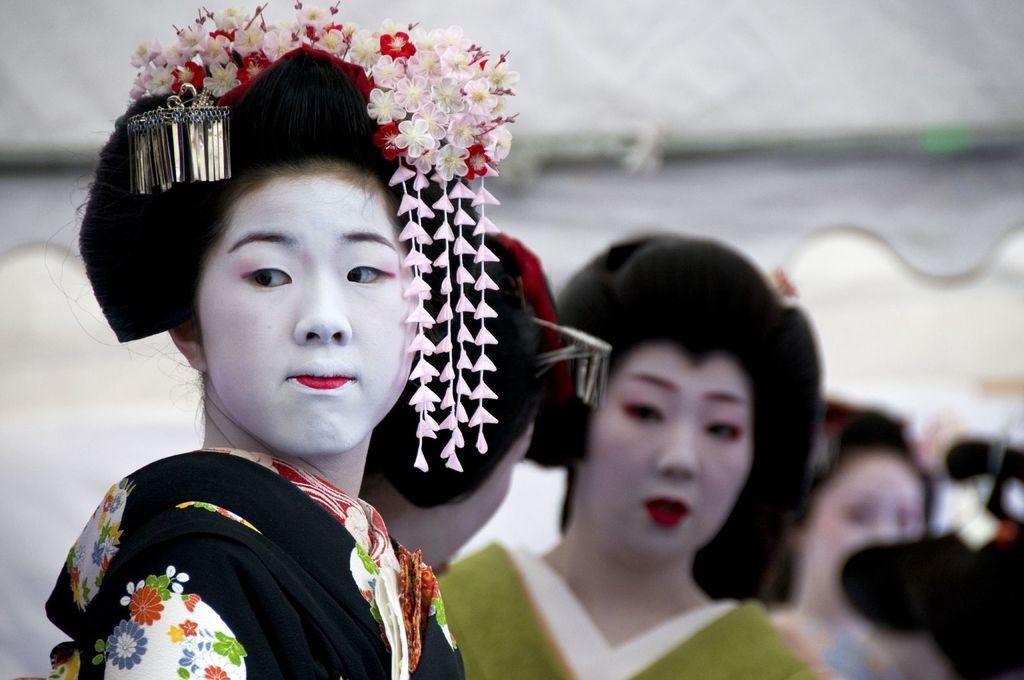How would you summarize this image in a sentence or two? In this image we can see many people. Lady in the front is having some flowers on the head. In the background it is looking blur. 